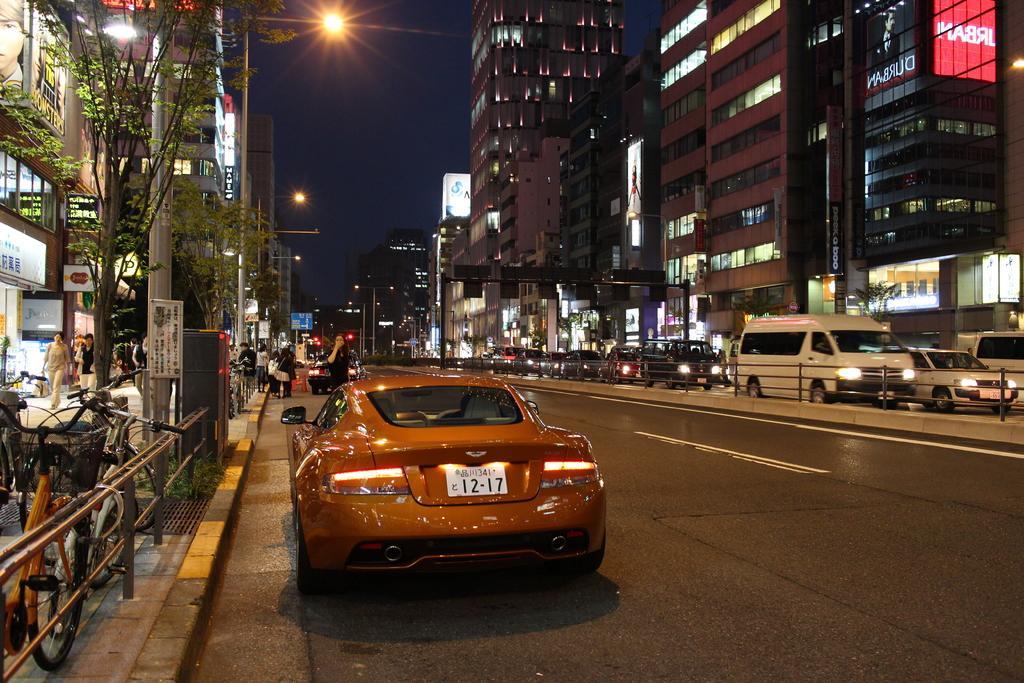How would you summarize this image in a sentence or two? In this image there are few cars are moving on the road. On the right and left side of the image there are buildings and stalls and few people are walking on the pavement and there two bicycles are parked, in front of the buildings there are trees. In the background there is a sky. 